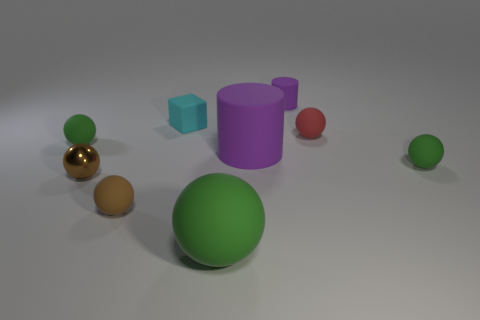Subtract all green spheres. How many were subtracted if there are1green spheres left? 2 Subtract all red cylinders. How many green spheres are left? 3 Subtract all large green spheres. How many spheres are left? 5 Subtract all red balls. How many balls are left? 5 Subtract all red balls. Subtract all green cylinders. How many balls are left? 5 Add 1 tiny cyan matte cubes. How many objects exist? 10 Subtract all cylinders. How many objects are left? 7 Subtract all large cylinders. Subtract all brown matte spheres. How many objects are left? 7 Add 7 cyan rubber objects. How many cyan rubber objects are left? 8 Add 4 purple matte cylinders. How many purple matte cylinders exist? 6 